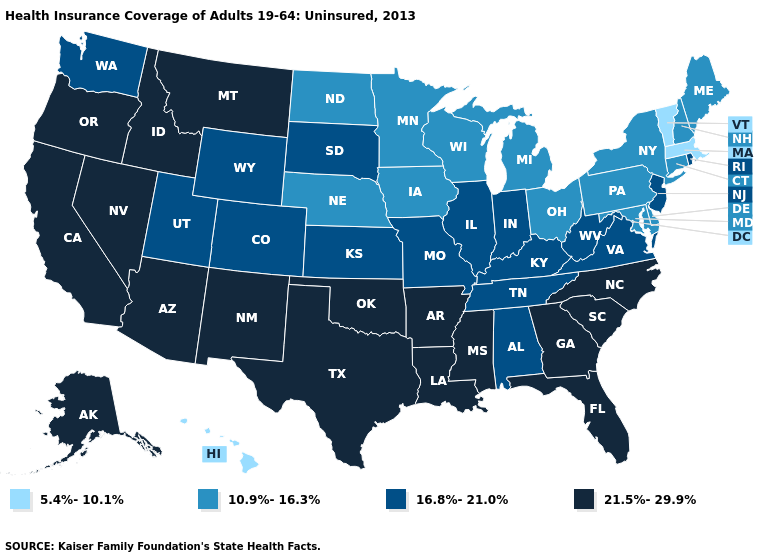Name the states that have a value in the range 16.8%-21.0%?
Write a very short answer. Alabama, Colorado, Illinois, Indiana, Kansas, Kentucky, Missouri, New Jersey, Rhode Island, South Dakota, Tennessee, Utah, Virginia, Washington, West Virginia, Wyoming. What is the value of Kansas?
Write a very short answer. 16.8%-21.0%. Which states hav the highest value in the MidWest?
Quick response, please. Illinois, Indiana, Kansas, Missouri, South Dakota. Does the first symbol in the legend represent the smallest category?
Be succinct. Yes. What is the lowest value in the USA?
Quick response, please. 5.4%-10.1%. What is the value of Rhode Island?
Be succinct. 16.8%-21.0%. Name the states that have a value in the range 21.5%-29.9%?
Give a very brief answer. Alaska, Arizona, Arkansas, California, Florida, Georgia, Idaho, Louisiana, Mississippi, Montana, Nevada, New Mexico, North Carolina, Oklahoma, Oregon, South Carolina, Texas. Does Wyoming have the lowest value in the West?
Write a very short answer. No. What is the lowest value in states that border Massachusetts?
Quick response, please. 5.4%-10.1%. Which states have the highest value in the USA?
Short answer required. Alaska, Arizona, Arkansas, California, Florida, Georgia, Idaho, Louisiana, Mississippi, Montana, Nevada, New Mexico, North Carolina, Oklahoma, Oregon, South Carolina, Texas. Among the states that border Arkansas , does Missouri have the lowest value?
Keep it brief. Yes. Which states have the highest value in the USA?
Short answer required. Alaska, Arizona, Arkansas, California, Florida, Georgia, Idaho, Louisiana, Mississippi, Montana, Nevada, New Mexico, North Carolina, Oklahoma, Oregon, South Carolina, Texas. Does Michigan have a lower value than Vermont?
Short answer required. No. What is the lowest value in the South?
Write a very short answer. 10.9%-16.3%. What is the highest value in states that border Maryland?
Keep it brief. 16.8%-21.0%. 